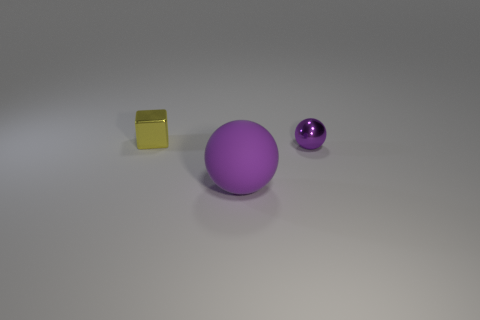Are there any other things that have the same size as the rubber thing?
Your response must be concise. No. Is there any other thing that has the same color as the small block?
Your answer should be very brief. No. There is a object that is both on the right side of the block and left of the small sphere; what size is it?
Offer a terse response. Large. There is a sphere that is in front of the tiny purple shiny ball; is it the same color as the metallic thing that is in front of the small block?
Provide a succinct answer. Yes. What number of other objects are there of the same material as the large purple object?
Ensure brevity in your answer.  0. There is a thing that is behind the purple matte thing and left of the tiny purple object; what is its shape?
Provide a succinct answer. Cube. There is a big ball; does it have the same color as the shiny object that is right of the big rubber ball?
Your answer should be very brief. Yes. Is the size of the thing behind the purple metallic object the same as the small purple metal sphere?
Provide a succinct answer. Yes. There is another object that is the same shape as the tiny purple thing; what material is it?
Offer a very short reply. Rubber. Does the yellow metal object have the same shape as the big purple object?
Offer a terse response. No. 